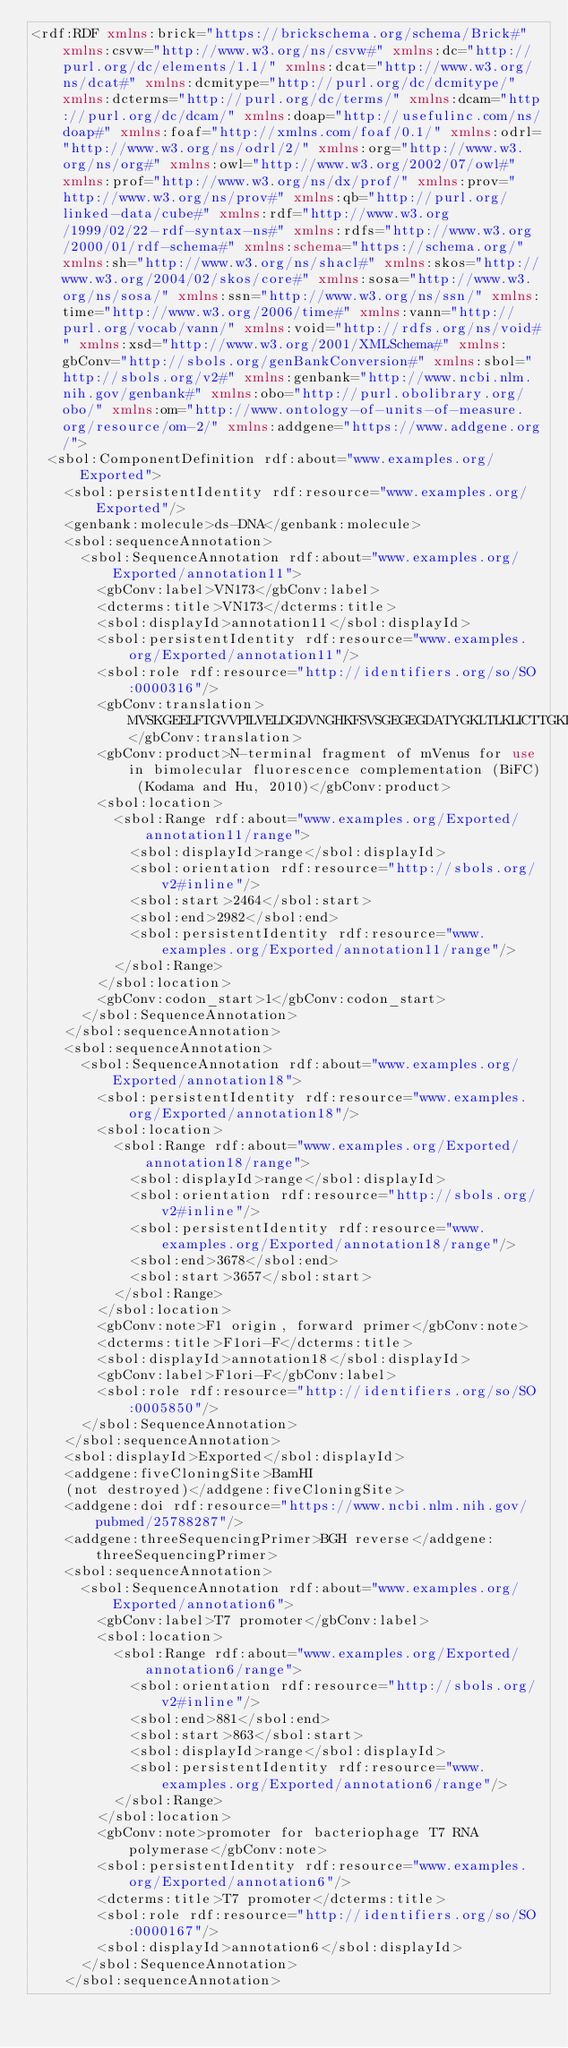Convert code to text. <code><loc_0><loc_0><loc_500><loc_500><_XML_><rdf:RDF xmlns:brick="https://brickschema.org/schema/Brick#" xmlns:csvw="http://www.w3.org/ns/csvw#" xmlns:dc="http://purl.org/dc/elements/1.1/" xmlns:dcat="http://www.w3.org/ns/dcat#" xmlns:dcmitype="http://purl.org/dc/dcmitype/" xmlns:dcterms="http://purl.org/dc/terms/" xmlns:dcam="http://purl.org/dc/dcam/" xmlns:doap="http://usefulinc.com/ns/doap#" xmlns:foaf="http://xmlns.com/foaf/0.1/" xmlns:odrl="http://www.w3.org/ns/odrl/2/" xmlns:org="http://www.w3.org/ns/org#" xmlns:owl="http://www.w3.org/2002/07/owl#" xmlns:prof="http://www.w3.org/ns/dx/prof/" xmlns:prov="http://www.w3.org/ns/prov#" xmlns:qb="http://purl.org/linked-data/cube#" xmlns:rdf="http://www.w3.org/1999/02/22-rdf-syntax-ns#" xmlns:rdfs="http://www.w3.org/2000/01/rdf-schema#" xmlns:schema="https://schema.org/" xmlns:sh="http://www.w3.org/ns/shacl#" xmlns:skos="http://www.w3.org/2004/02/skos/core#" xmlns:sosa="http://www.w3.org/ns/sosa/" xmlns:ssn="http://www.w3.org/ns/ssn/" xmlns:time="http://www.w3.org/2006/time#" xmlns:vann="http://purl.org/vocab/vann/" xmlns:void="http://rdfs.org/ns/void#" xmlns:xsd="http://www.w3.org/2001/XMLSchema#" xmlns:gbConv="http://sbols.org/genBankConversion#" xmlns:sbol="http://sbols.org/v2#" xmlns:genbank="http://www.ncbi.nlm.nih.gov/genbank#" xmlns:obo="http://purl.obolibrary.org/obo/" xmlns:om="http://www.ontology-of-units-of-measure.org/resource/om-2/" xmlns:addgene="https://www.addgene.org/">
  <sbol:ComponentDefinition rdf:about="www.examples.org/Exported">
    <sbol:persistentIdentity rdf:resource="www.examples.org/Exported"/>
    <genbank:molecule>ds-DNA</genbank:molecule>
    <sbol:sequenceAnnotation>
      <sbol:SequenceAnnotation rdf:about="www.examples.org/Exported/annotation11">
        <gbConv:label>VN173</gbConv:label>
        <dcterms:title>VN173</dcterms:title>
        <sbol:displayId>annotation11</sbol:displayId>
        <sbol:persistentIdentity rdf:resource="www.examples.org/Exported/annotation11"/>
        <sbol:role rdf:resource="http://identifiers.org/so/SO:0000316"/>
        <gbConv:translation>MVSKGEELFTGVVPILVELDGDVNGHKFSVSGEGEGDATYGKLTLKLICTTGKLPVPWPTLVTTLGYGLQCFARYPDHMKQHDFFKSAMPEGYVQERTIFFKDDGNYKTRAEVKFEGDTLVNRIELKGIDFKEDGNILGHKLEYNYNSHNVYITADKQKNGIKANFKIRHNIE</gbConv:translation>
        <gbConv:product>N-terminal fragment of mVenus for use in bimolecular fluorescence complementation (BiFC) (Kodama and Hu, 2010)</gbConv:product>
        <sbol:location>
          <sbol:Range rdf:about="www.examples.org/Exported/annotation11/range">
            <sbol:displayId>range</sbol:displayId>
            <sbol:orientation rdf:resource="http://sbols.org/v2#inline"/>
            <sbol:start>2464</sbol:start>
            <sbol:end>2982</sbol:end>
            <sbol:persistentIdentity rdf:resource="www.examples.org/Exported/annotation11/range"/>
          </sbol:Range>
        </sbol:location>
        <gbConv:codon_start>1</gbConv:codon_start>
      </sbol:SequenceAnnotation>
    </sbol:sequenceAnnotation>
    <sbol:sequenceAnnotation>
      <sbol:SequenceAnnotation rdf:about="www.examples.org/Exported/annotation18">
        <sbol:persistentIdentity rdf:resource="www.examples.org/Exported/annotation18"/>
        <sbol:location>
          <sbol:Range rdf:about="www.examples.org/Exported/annotation18/range">
            <sbol:displayId>range</sbol:displayId>
            <sbol:orientation rdf:resource="http://sbols.org/v2#inline"/>
            <sbol:persistentIdentity rdf:resource="www.examples.org/Exported/annotation18/range"/>
            <sbol:end>3678</sbol:end>
            <sbol:start>3657</sbol:start>
          </sbol:Range>
        </sbol:location>
        <gbConv:note>F1 origin, forward primer</gbConv:note>
        <dcterms:title>F1ori-F</dcterms:title>
        <sbol:displayId>annotation18</sbol:displayId>
        <gbConv:label>F1ori-F</gbConv:label>
        <sbol:role rdf:resource="http://identifiers.org/so/SO:0005850"/>
      </sbol:SequenceAnnotation>
    </sbol:sequenceAnnotation>
    <sbol:displayId>Exported</sbol:displayId>
    <addgene:fiveCloningSite>BamHI
    (not destroyed)</addgene:fiveCloningSite>
    <addgene:doi rdf:resource="https://www.ncbi.nlm.nih.gov/pubmed/25788287"/>
    <addgene:threeSequencingPrimer>BGH reverse</addgene:threeSequencingPrimer>
    <sbol:sequenceAnnotation>
      <sbol:SequenceAnnotation rdf:about="www.examples.org/Exported/annotation6">
        <gbConv:label>T7 promoter</gbConv:label>
        <sbol:location>
          <sbol:Range rdf:about="www.examples.org/Exported/annotation6/range">
            <sbol:orientation rdf:resource="http://sbols.org/v2#inline"/>
            <sbol:end>881</sbol:end>
            <sbol:start>863</sbol:start>
            <sbol:displayId>range</sbol:displayId>
            <sbol:persistentIdentity rdf:resource="www.examples.org/Exported/annotation6/range"/>
          </sbol:Range>
        </sbol:location>
        <gbConv:note>promoter for bacteriophage T7 RNA polymerase</gbConv:note>
        <sbol:persistentIdentity rdf:resource="www.examples.org/Exported/annotation6"/>
        <dcterms:title>T7 promoter</dcterms:title>
        <sbol:role rdf:resource="http://identifiers.org/so/SO:0000167"/>
        <sbol:displayId>annotation6</sbol:displayId>
      </sbol:SequenceAnnotation>
    </sbol:sequenceAnnotation></code> 